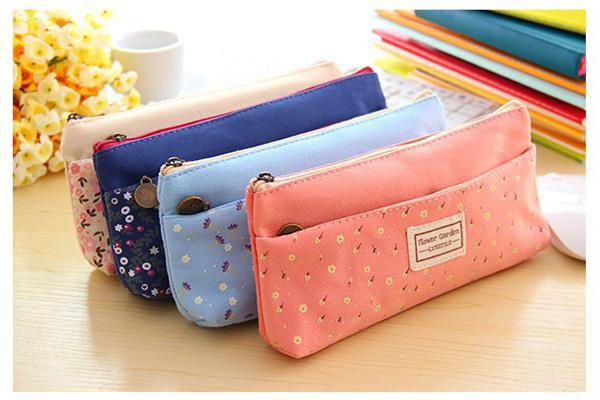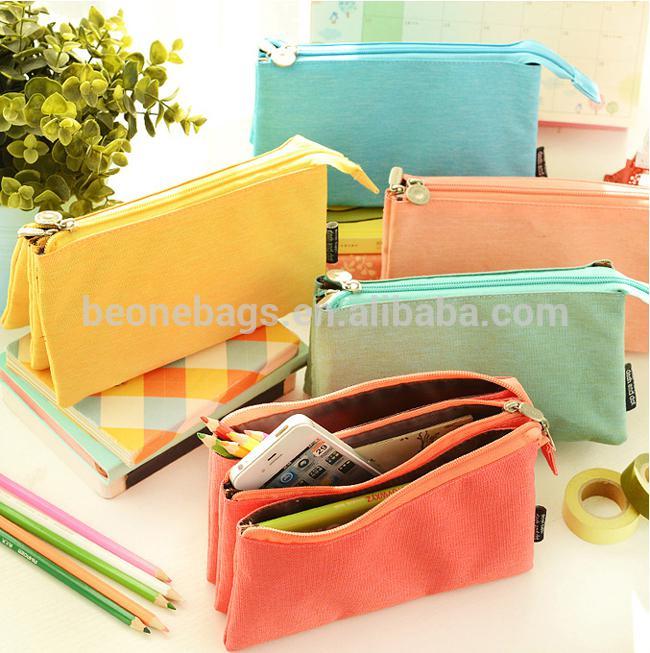The first image is the image on the left, the second image is the image on the right. Examine the images to the left and right. Is the description "Contents are poking out of one of the bags in the image on the left." accurate? Answer yes or no. No. 